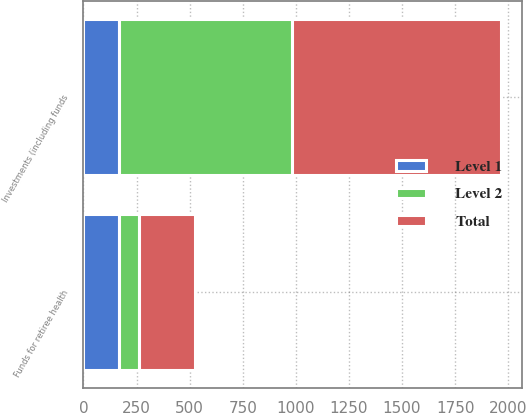Convert chart. <chart><loc_0><loc_0><loc_500><loc_500><stacked_bar_chart><ecel><fcel>Funds for retiree health<fcel>Investments (including funds<nl><fcel>Level 1<fcel>168<fcel>168<nl><fcel>Level 2<fcel>94<fcel>816<nl><fcel>Total<fcel>262<fcel>984<nl></chart> 